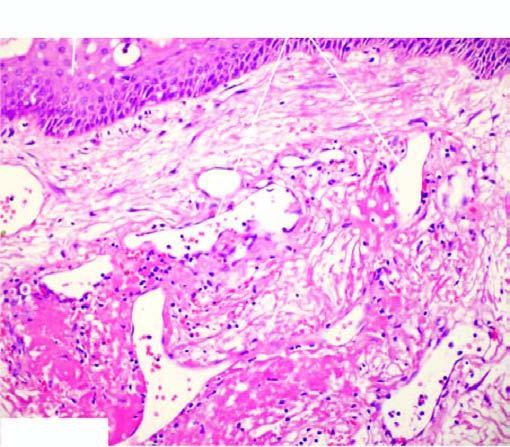does the alveolar septa have intact surface epithelium?
Answer the question using a single word or phrase. No 